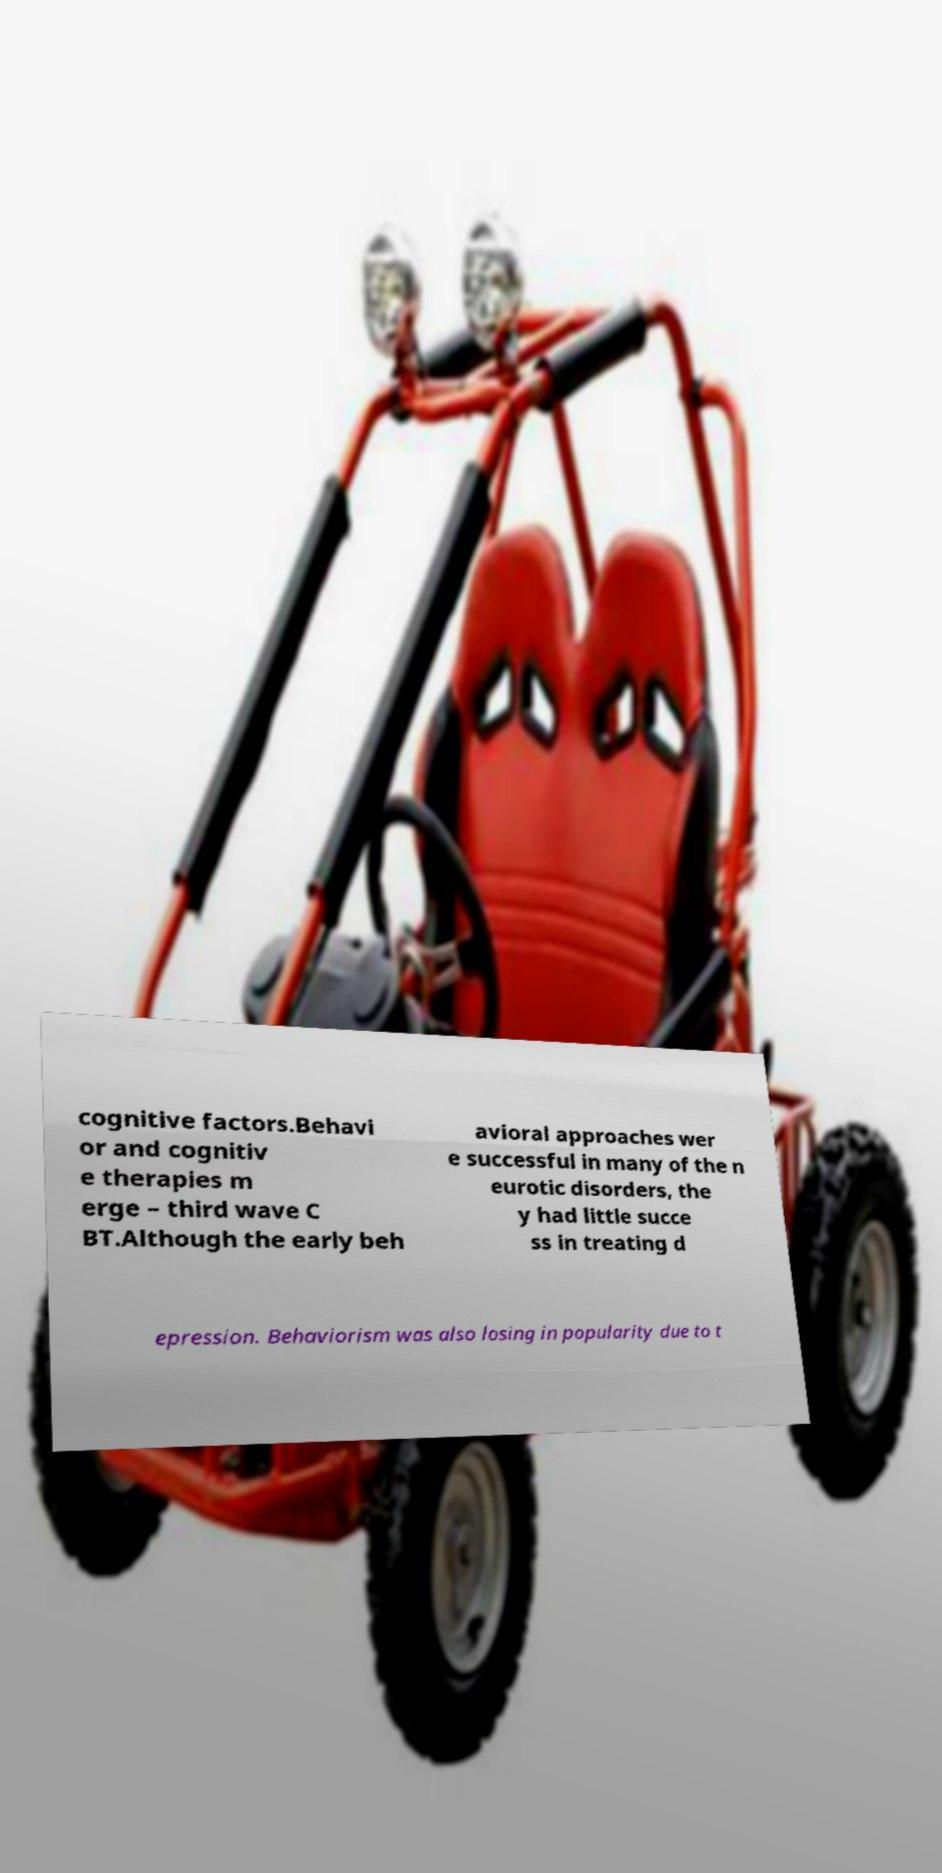Please read and relay the text visible in this image. What does it say? cognitive factors.Behavi or and cognitiv e therapies m erge – third wave C BT.Although the early beh avioral approaches wer e successful in many of the n eurotic disorders, the y had little succe ss in treating d epression. Behaviorism was also losing in popularity due to t 